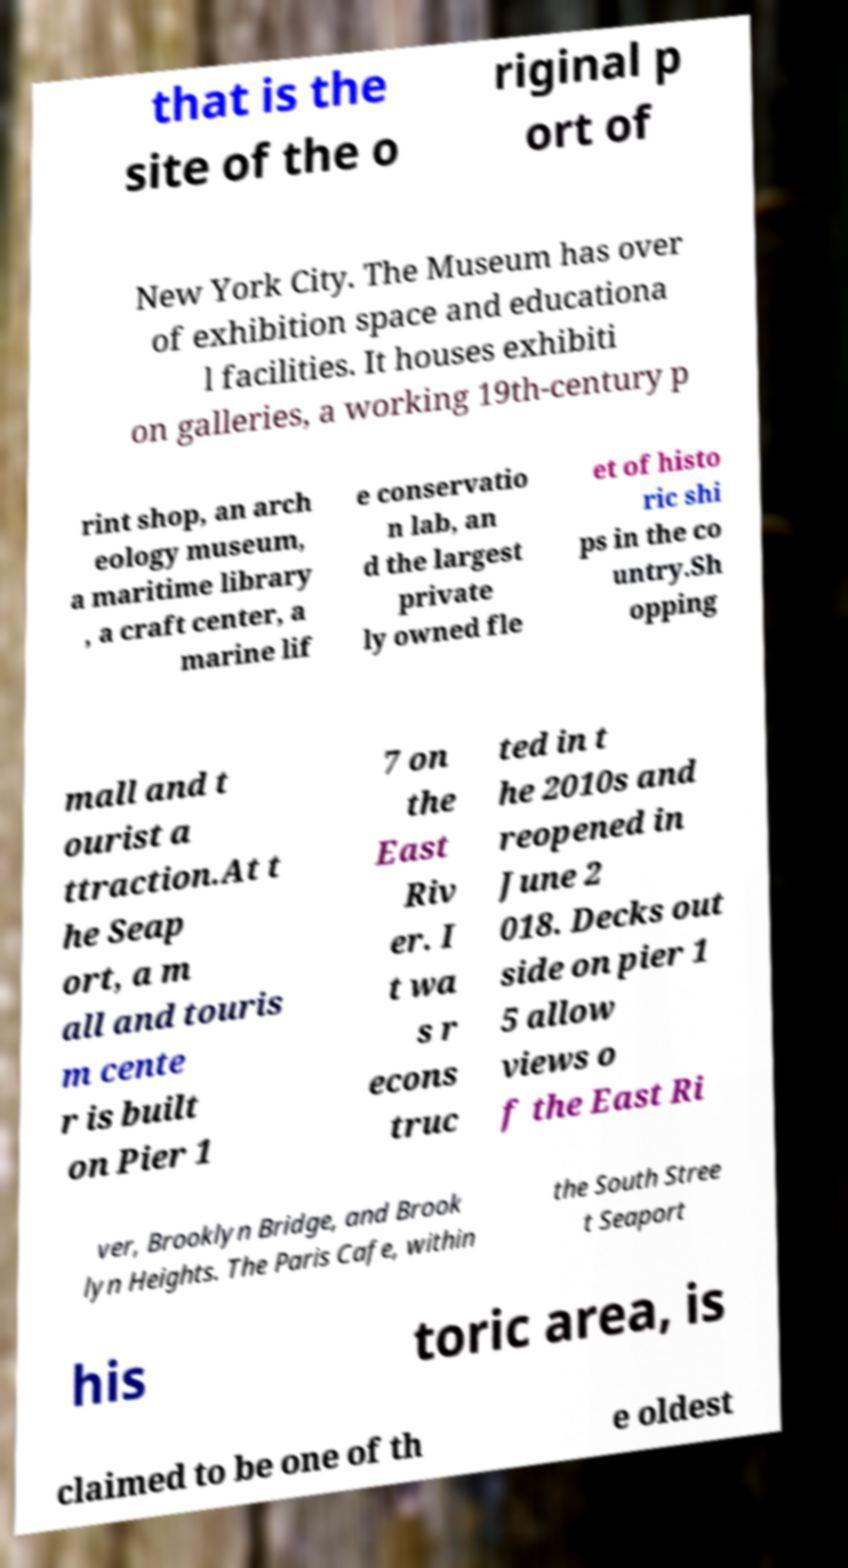There's text embedded in this image that I need extracted. Can you transcribe it verbatim? that is the site of the o riginal p ort of New York City. The Museum has over of exhibition space and educationa l facilities. It houses exhibiti on galleries, a working 19th-century p rint shop, an arch eology museum, a maritime library , a craft center, a marine lif e conservatio n lab, an d the largest private ly owned fle et of histo ric shi ps in the co untry.Sh opping mall and t ourist a ttraction.At t he Seap ort, a m all and touris m cente r is built on Pier 1 7 on the East Riv er. I t wa s r econs truc ted in t he 2010s and reopened in June 2 018. Decks out side on pier 1 5 allow views o f the East Ri ver, Brooklyn Bridge, and Brook lyn Heights. The Paris Cafe, within the South Stree t Seaport his toric area, is claimed to be one of th e oldest 